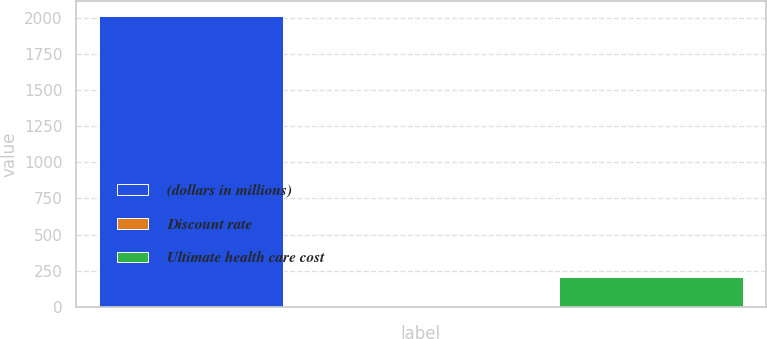<chart> <loc_0><loc_0><loc_500><loc_500><bar_chart><fcel>(dollars in millions)<fcel>Discount rate<fcel>Ultimate health care cost<nl><fcel>2016<fcel>3.93<fcel>205.14<nl></chart> 